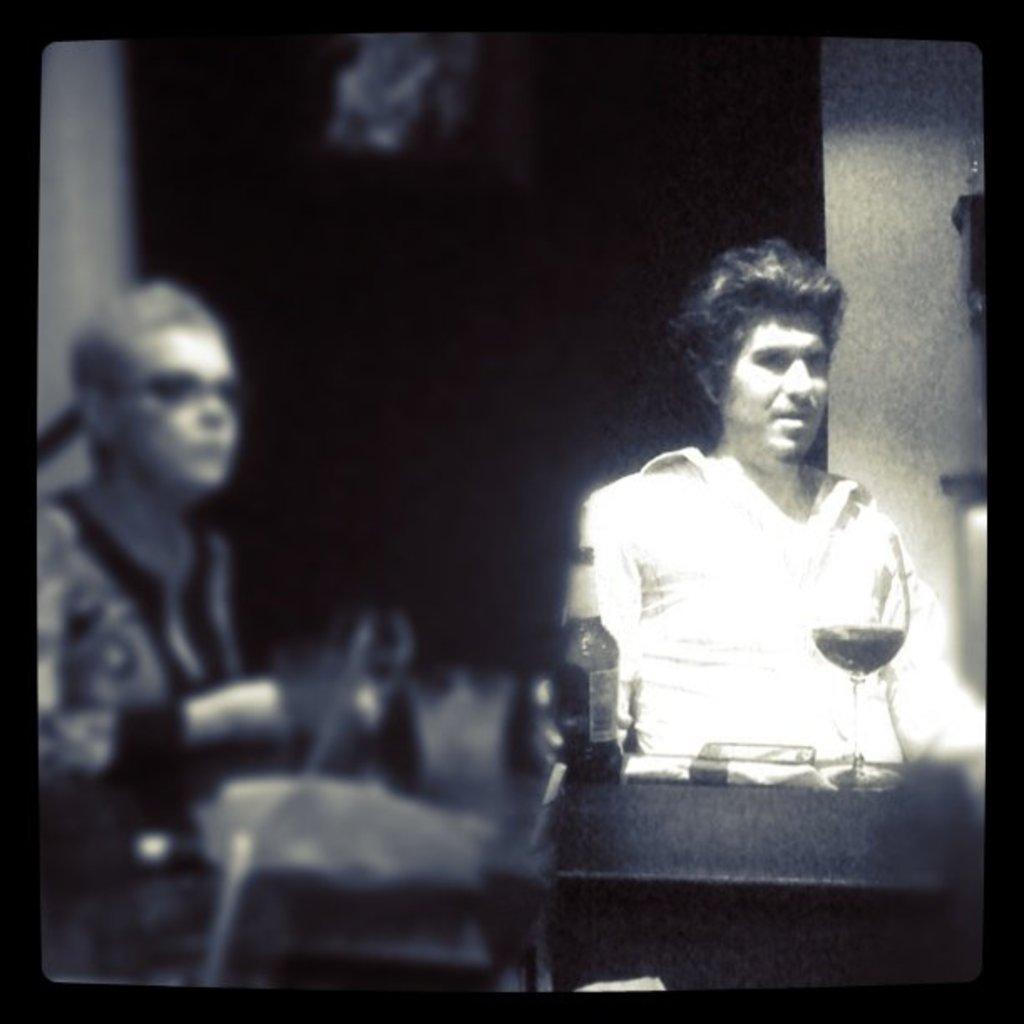Describe this image in one or two sentences. In the center of the image there are two persons. 